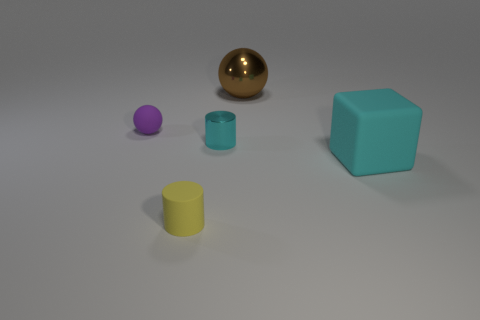There is a metallic object behind the matte ball; what is its size?
Your response must be concise. Large. Is there a cyan rubber object that has the same size as the cyan rubber cube?
Provide a succinct answer. No. There is a metallic object to the left of the brown metallic sphere; does it have the same size as the yellow cylinder?
Make the answer very short. Yes. What size is the cube?
Give a very brief answer. Large. There is a tiny matte object behind the big thing that is in front of the metallic object in front of the brown shiny object; what color is it?
Provide a succinct answer. Purple. Do the large thing in front of the brown thing and the tiny metallic cylinder have the same color?
Your answer should be compact. Yes. What number of objects are both left of the brown ball and in front of the matte sphere?
Give a very brief answer. 2. What is the size of the yellow matte object that is the same shape as the cyan metallic thing?
Offer a terse response. Small. There is a cyan object to the left of the large thing that is behind the metal cylinder; how many rubber blocks are behind it?
Your answer should be compact. 0. What is the color of the object on the right side of the large thing that is behind the small metal object?
Offer a very short reply. Cyan. 